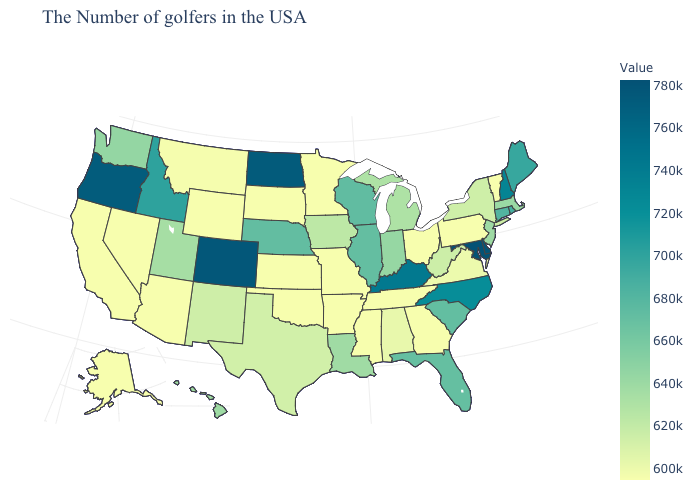Which states have the highest value in the USA?
Give a very brief answer. Maryland. Does Ohio have the highest value in the MidWest?
Answer briefly. No. Is the legend a continuous bar?
Quick response, please. Yes. Which states hav the highest value in the West?
Keep it brief. Colorado. Does Iowa have a higher value than Virginia?
Answer briefly. Yes. 